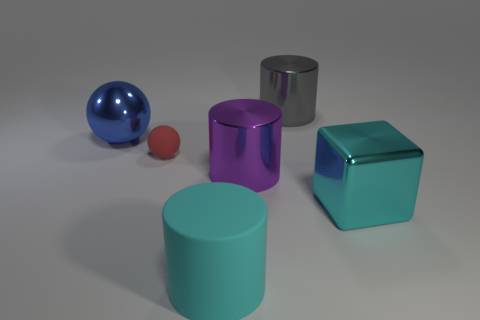Are there any objects with reflective surfaces, and if so, which ones? Yes, the silver cylinder has a reflective metallic surface that can mirror the environment, and so does the blue sphere, which appears to have a glossy finish. 